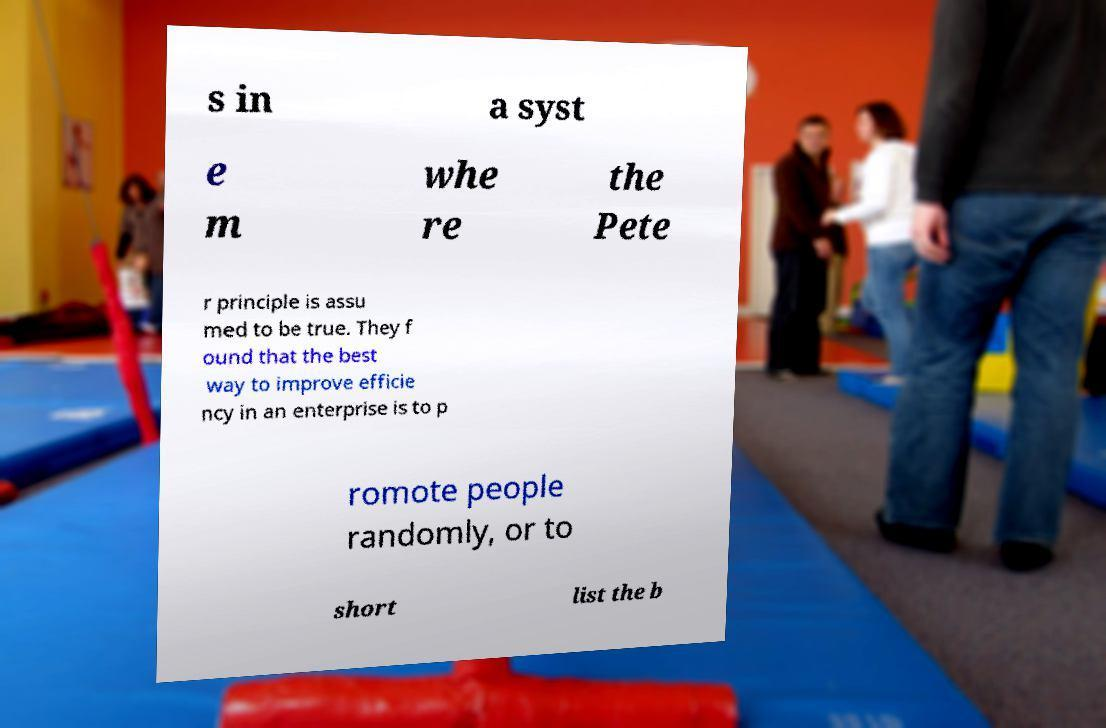Please read and relay the text visible in this image. What does it say? s in a syst e m whe re the Pete r principle is assu med to be true. They f ound that the best way to improve efficie ncy in an enterprise is to p romote people randomly, or to short list the b 